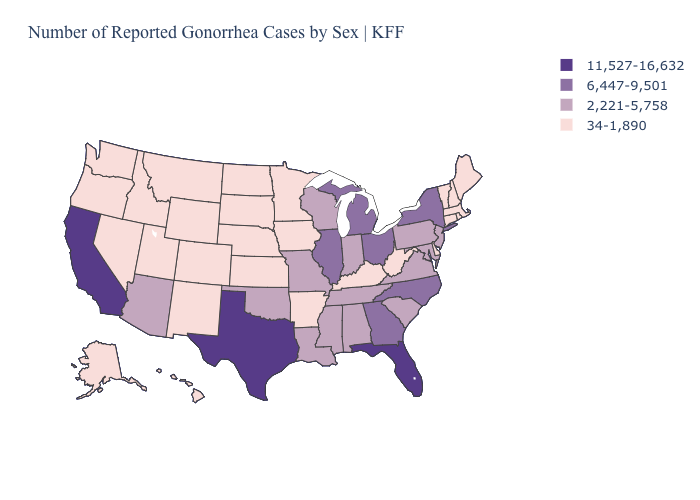What is the lowest value in the USA?
Write a very short answer. 34-1,890. Which states have the lowest value in the Northeast?
Keep it brief. Connecticut, Maine, Massachusetts, New Hampshire, Rhode Island, Vermont. What is the value of Louisiana?
Answer briefly. 2,221-5,758. What is the value of South Dakota?
Give a very brief answer. 34-1,890. What is the value of West Virginia?
Give a very brief answer. 34-1,890. Which states have the highest value in the USA?
Keep it brief. California, Florida, Texas. Name the states that have a value in the range 11,527-16,632?
Give a very brief answer. California, Florida, Texas. What is the highest value in states that border Utah?
Write a very short answer. 2,221-5,758. Does North Carolina have the lowest value in the USA?
Concise answer only. No. Does Illinois have the lowest value in the USA?
Give a very brief answer. No. Which states have the highest value in the USA?
Keep it brief. California, Florida, Texas. What is the value of North Carolina?
Write a very short answer. 6,447-9,501. How many symbols are there in the legend?
Write a very short answer. 4. What is the value of Rhode Island?
Be succinct. 34-1,890. Among the states that border New Mexico , which have the highest value?
Write a very short answer. Texas. 